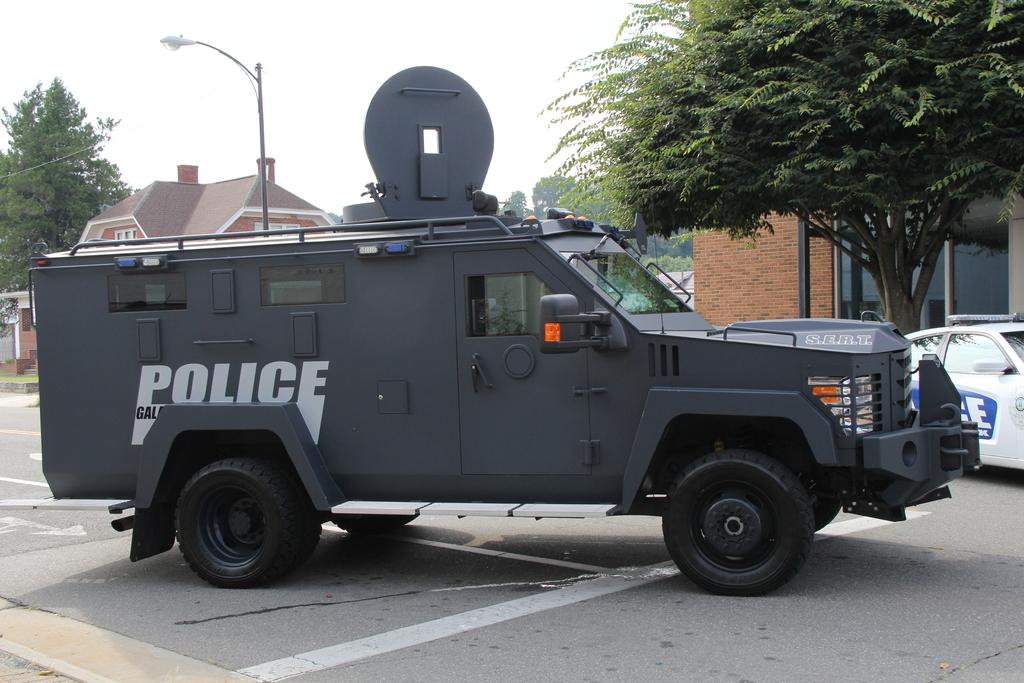What can be seen on the road in the image? There are vehicles on the road in the image. What else is visible in the image besides the vehicles? There are buildings and trees visible in the image. What is visible in the background of the image? The sky is visible in the background of the image. How many chairs can be seen in the image? There are no chairs present in the image. What is the aftermath of the engine explosion in the image? There is no engine explosion or any related aftermath in the image. 